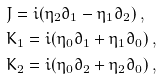<formula> <loc_0><loc_0><loc_500><loc_500>& J = i ( \eta _ { 2 } \partial _ { 1 } - \eta _ { 1 } \partial _ { 2 } ) \, , \\ & K _ { 1 } = i ( \eta _ { 0 } \partial _ { 1 } + \eta _ { 1 } \partial _ { 0 } ) \, , \\ & K _ { 2 } = i ( \eta _ { 0 } \partial _ { 2 } + \eta _ { 2 } \partial _ { 0 } ) \, ,</formula> 